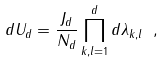<formula> <loc_0><loc_0><loc_500><loc_500>d U _ { d } = \frac { J _ { d } } { N _ { d } } \prod _ { k , l = 1 } ^ { d } d \lambda _ { k , l } \ ,</formula> 